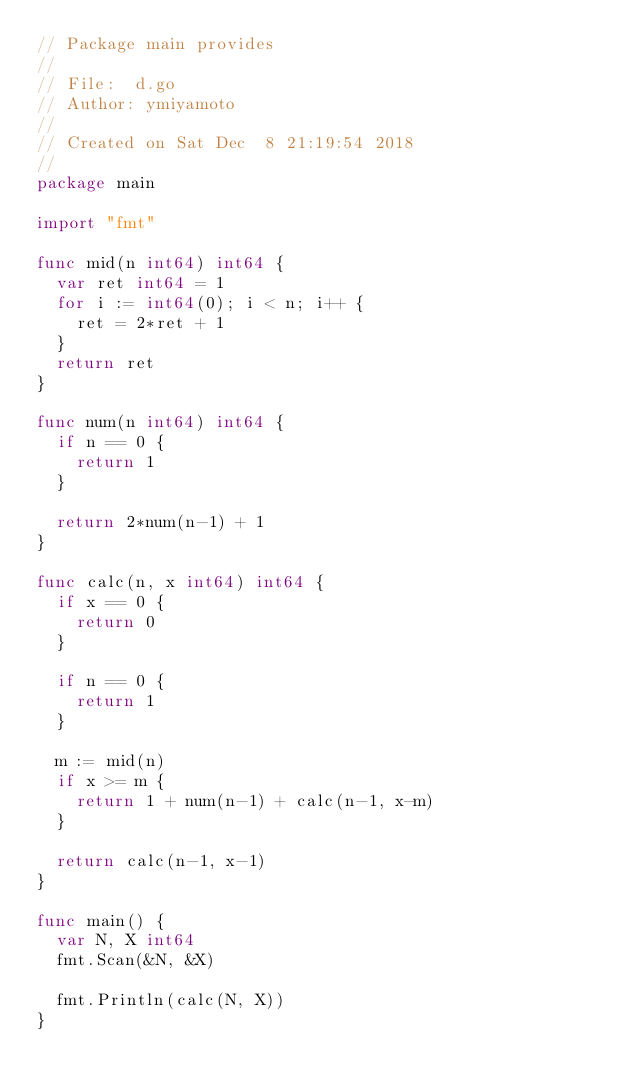<code> <loc_0><loc_0><loc_500><loc_500><_Go_>// Package main provides
//
// File:  d.go
// Author: ymiyamoto
//
// Created on Sat Dec  8 21:19:54 2018
//
package main

import "fmt"

func mid(n int64) int64 {
	var ret int64 = 1
	for i := int64(0); i < n; i++ {
		ret = 2*ret + 1
	}
	return ret
}

func num(n int64) int64 {
	if n == 0 {
		return 1
	}

	return 2*num(n-1) + 1
}

func calc(n, x int64) int64 {
	if x == 0 {
		return 0
	}

	if n == 0 {
		return 1
	}

	m := mid(n)
	if x >= m {
		return 1 + num(n-1) + calc(n-1, x-m)
	}

	return calc(n-1, x-1)
}

func main() {
	var N, X int64
	fmt.Scan(&N, &X)

	fmt.Println(calc(N, X))
}
</code> 